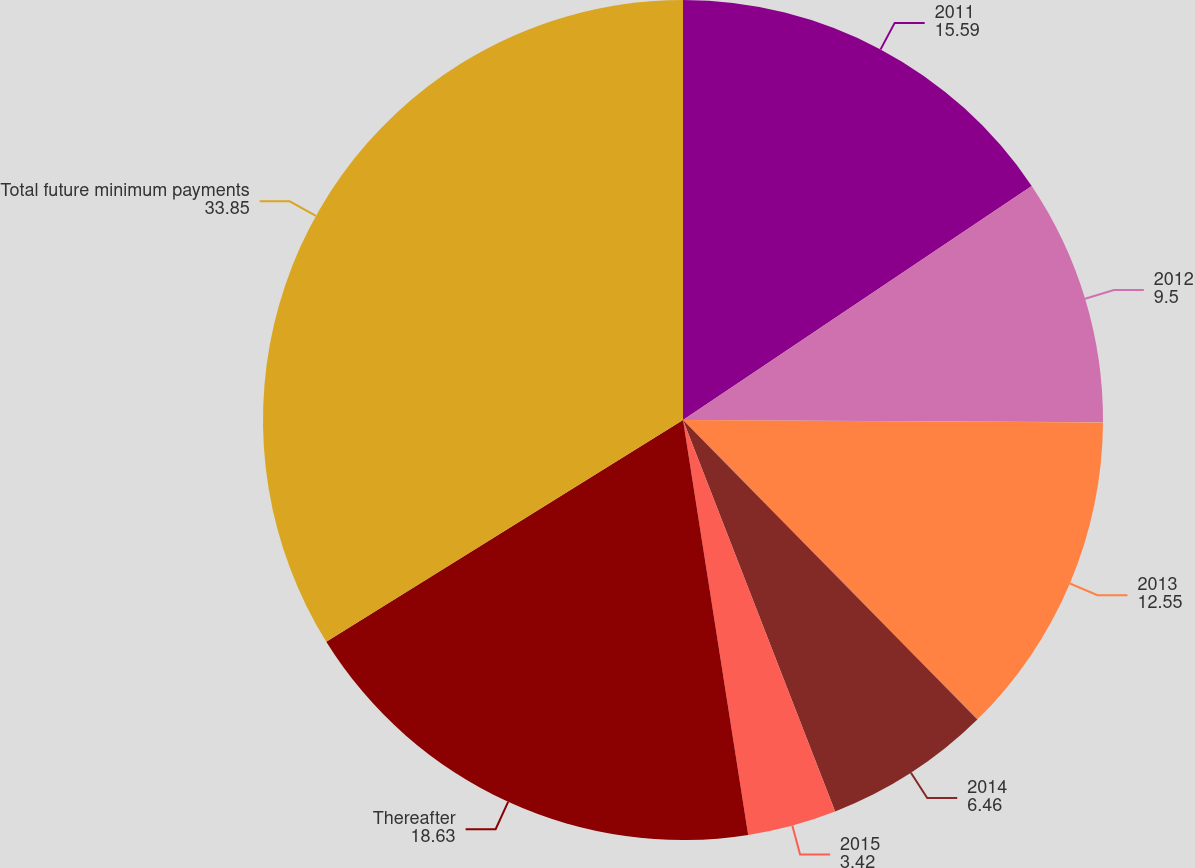Convert chart. <chart><loc_0><loc_0><loc_500><loc_500><pie_chart><fcel>2011<fcel>2012<fcel>2013<fcel>2014<fcel>2015<fcel>Thereafter<fcel>Total future minimum payments<nl><fcel>15.59%<fcel>9.5%<fcel>12.55%<fcel>6.46%<fcel>3.42%<fcel>18.63%<fcel>33.85%<nl></chart> 